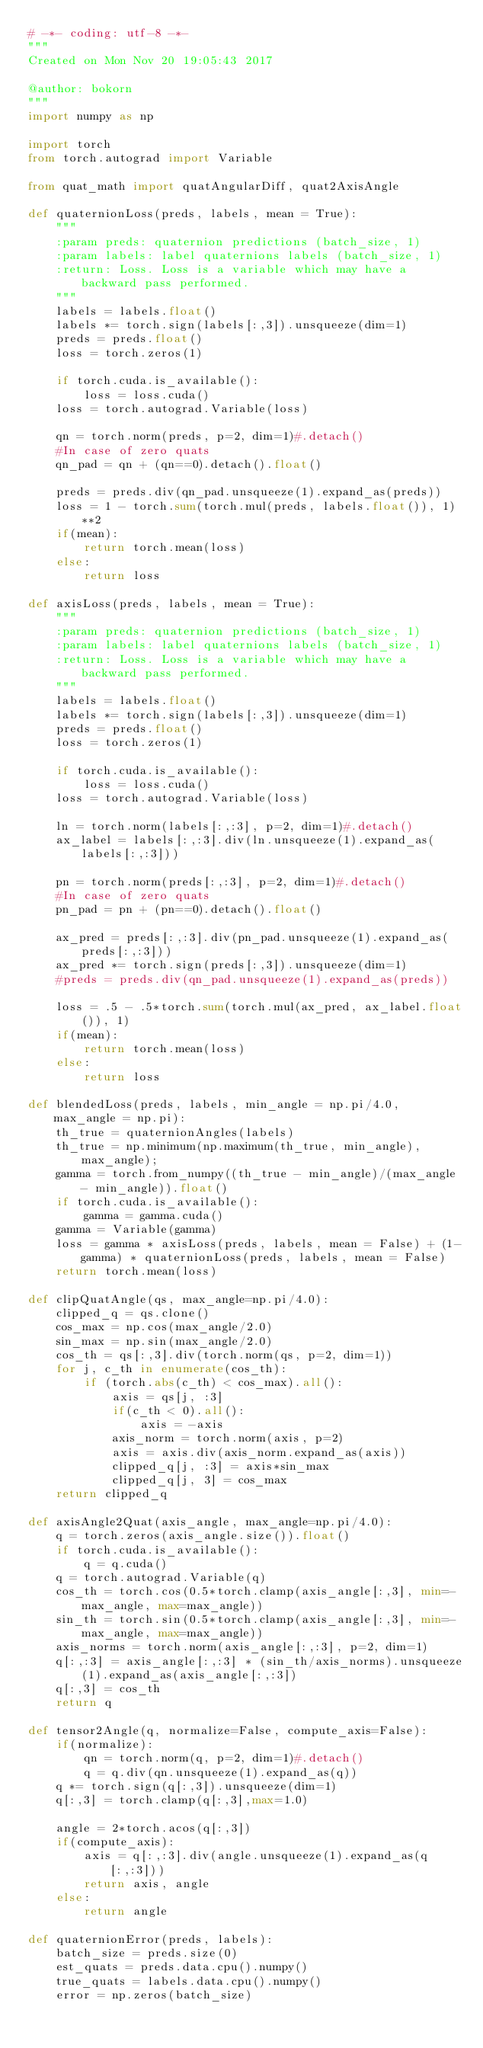<code> <loc_0><loc_0><loc_500><loc_500><_Python_># -*- coding: utf-8 -*-
"""
Created on Mon Nov 20 19:05:43 2017

@author: bokorn
"""
import numpy as np 

import torch
from torch.autograd import Variable

from quat_math import quatAngularDiff, quat2AxisAngle

def quaternionLoss(preds, labels, mean = True):
    """
    :param preds: quaternion predictions (batch_size, 1)
    :param labels: label quaternions labels (batch_size, 1)
    :return: Loss. Loss is a variable which may have a backward pass performed.
    """
    labels = labels.float()
    labels *= torch.sign(labels[:,3]).unsqueeze(dim=1)
    preds = preds.float()
    loss = torch.zeros(1)

    if torch.cuda.is_available():
        loss = loss.cuda()
    loss = torch.autograd.Variable(loss)
    
    qn = torch.norm(preds, p=2, dim=1)#.detach()
    #In case of zero quats
    qn_pad = qn + (qn==0).detach().float()
    
    preds = preds.div(qn_pad.unsqueeze(1).expand_as(preds))
    loss = 1 - torch.sum(torch.mul(preds, labels.float()), 1)**2
    if(mean):
        return torch.mean(loss)
    else:
        return loss

def axisLoss(preds, labels, mean = True):
    """
    :param preds: quaternion predictions (batch_size, 1)
    :param labels: label quaternions labels (batch_size, 1)
    :return: Loss. Loss is a variable which may have a backward pass performed.
    """
    labels = labels.float()
    labels *= torch.sign(labels[:,3]).unsqueeze(dim=1)
    preds = preds.float()
    loss = torch.zeros(1)

    if torch.cuda.is_available():
        loss = loss.cuda()
    loss = torch.autograd.Variable(loss)
    
    ln = torch.norm(labels[:,:3], p=2, dim=1)#.detach()
    ax_label = labels[:,:3].div(ln.unsqueeze(1).expand_as(labels[:,:3]))
    
    pn = torch.norm(preds[:,:3], p=2, dim=1)#.detach()
    #In case of zero quats
    pn_pad = pn + (pn==0).detach().float()
    
    ax_pred = preds[:,:3].div(pn_pad.unsqueeze(1).expand_as(preds[:,:3]))
    ax_pred *= torch.sign(preds[:,3]).unsqueeze(dim=1)
    #preds = preds.div(qn_pad.unsqueeze(1).expand_as(preds))
    
    loss = .5 - .5*torch.sum(torch.mul(ax_pred, ax_label.float()), 1)
    if(mean):
        return torch.mean(loss)
    else:
        return loss

def blendedLoss(preds, labels, min_angle = np.pi/4.0, max_angle = np.pi):
    th_true = quaternionAngles(labels)
    th_true = np.minimum(np.maximum(th_true, min_angle), max_angle);
    gamma = torch.from_numpy((th_true - min_angle)/(max_angle - min_angle)).float()
    if torch.cuda.is_available():
        gamma = gamma.cuda()
    gamma = Variable(gamma)
    loss = gamma * axisLoss(preds, labels, mean = False) + (1-gamma) * quaternionLoss(preds, labels, mean = False)
    return torch.mean(loss)

def clipQuatAngle(qs, max_angle=np.pi/4.0):
    clipped_q = qs.clone()
    cos_max = np.cos(max_angle/2.0)
    sin_max = np.sin(max_angle/2.0)
    cos_th = qs[:,3].div(torch.norm(qs, p=2, dim=1))
    for j, c_th in enumerate(cos_th):
        if (torch.abs(c_th) < cos_max).all():
            axis = qs[j, :3]
            if(c_th < 0).all():
                axis = -axis
            axis_norm = torch.norm(axis, p=2)
            axis = axis.div(axis_norm.expand_as(axis))
            clipped_q[j, :3] = axis*sin_max
            clipped_q[j, 3] = cos_max
    return clipped_q

def axisAngle2Quat(axis_angle, max_angle=np.pi/4.0):
    q = torch.zeros(axis_angle.size()).float()
    if torch.cuda.is_available():
        q = q.cuda()
    q = torch.autograd.Variable(q)
    cos_th = torch.cos(0.5*torch.clamp(axis_angle[:,3], min=-max_angle, max=max_angle))
    sin_th = torch.sin(0.5*torch.clamp(axis_angle[:,3], min=-max_angle, max=max_angle))
    axis_norms = torch.norm(axis_angle[:,:3], p=2, dim=1)
    q[:,:3] = axis_angle[:,:3] * (sin_th/axis_norms).unsqueeze(1).expand_as(axis_angle[:,:3])
    q[:,3] = cos_th
    return q

def tensor2Angle(q, normalize=False, compute_axis=False):
    if(normalize):
        qn = torch.norm(q, p=2, dim=1)#.detach()
        q = q.div(qn.unsqueeze(1).expand_as(q))
    q *= torch.sign(q[:,3]).unsqueeze(dim=1)
    q[:,3] = torch.clamp(q[:,3],max=1.0)

    angle = 2*torch.acos(q[:,3])
    if(compute_axis):
        axis = q[:,:3].div(angle.unsqueeze(1).expand_as(q[:,:3]))
        return axis, angle
    else:
        return angle
    
def quaternionError(preds, labels):
    batch_size = preds.size(0)
    est_quats = preds.data.cpu().numpy()
    true_quats = labels.data.cpu().numpy()
    error = np.zeros(batch_size)</code> 